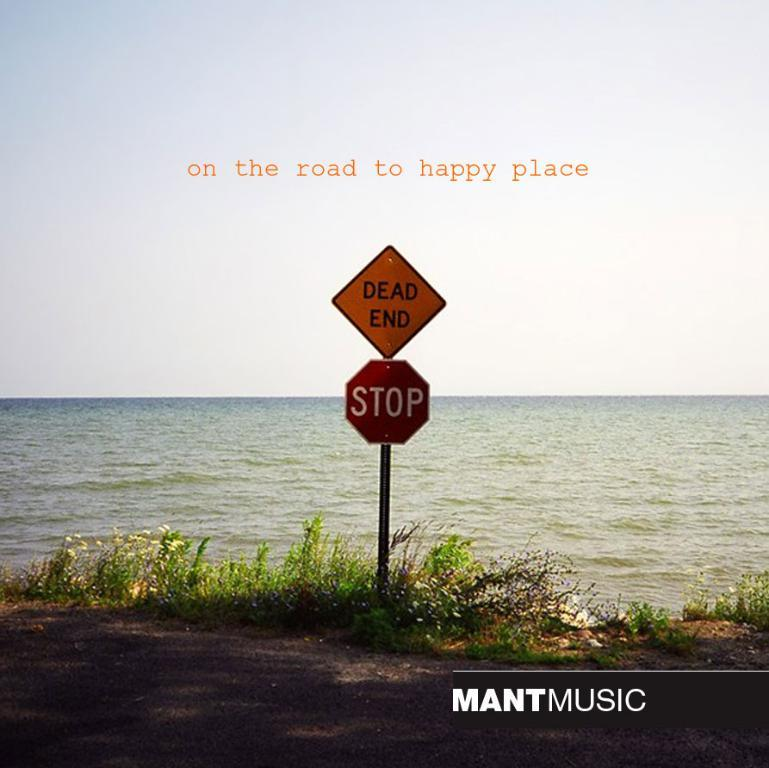<image>
Render a clear and concise summary of the photo. Right where the water meets the road are signs saying dead end and stop. 